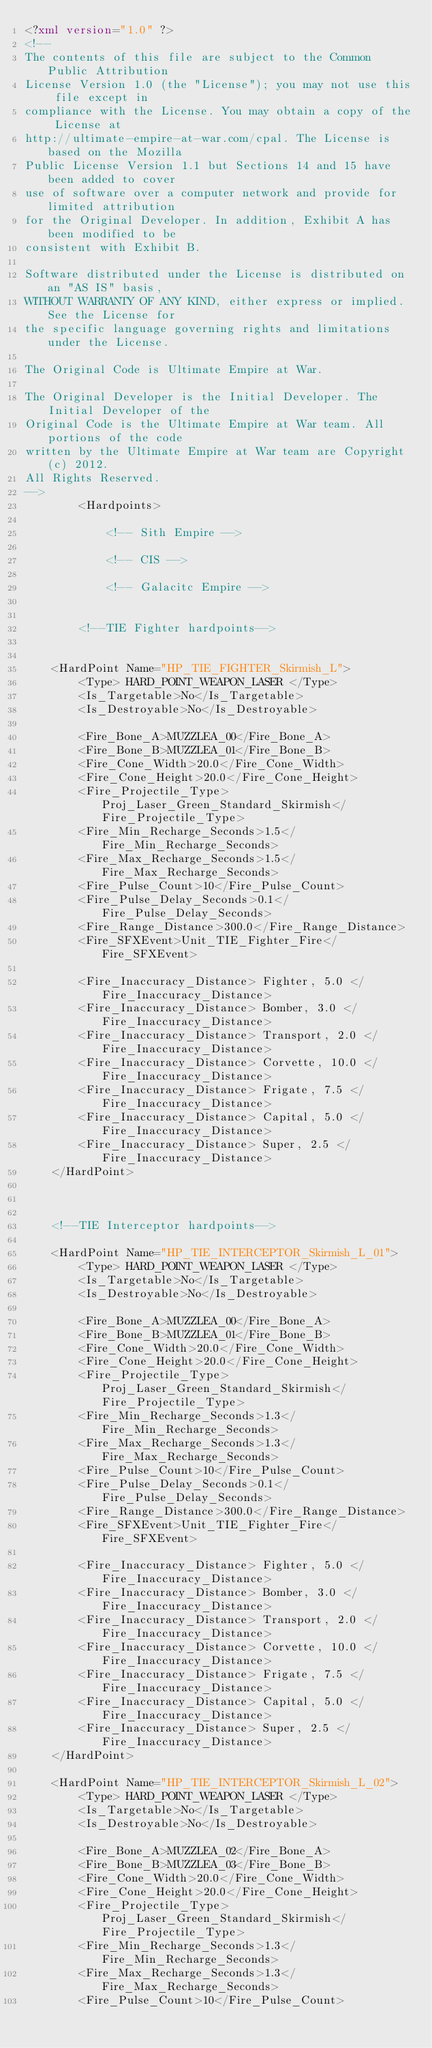Convert code to text. <code><loc_0><loc_0><loc_500><loc_500><_XML_><?xml version="1.0" ?>
<!--
The contents of this file are subject to the Common Public Attribution
License Version 1.0 (the "License"); you may not use this file except in
compliance with the License. You may obtain a copy of the License at
http://ultimate-empire-at-war.com/cpal. The License is based on the Mozilla
Public License Version 1.1 but Sections 14 and 15 have been added to cover
use of software over a computer network and provide for limited attribution
for the Original Developer. In addition, Exhibit A has been modified to be
consistent with Exhibit B.
    
Software distributed under the License is distributed on an "AS IS" basis,
WITHOUT WARRANTY OF ANY KIND, either express or implied. See the License for
the specific language governing rights and limitations under the License.
    
The Original Code is Ultimate Empire at War.
    
The Original Developer is the Initial Developer. The Initial Developer of the
Original Code is the Ultimate Empire at War team. All portions of the code
written by the Ultimate Empire at War team are Copyright (c) 2012.
All Rights Reserved.
-->
        <Hardpoints>

            <!-- Sith Empire -->

            <!-- CIS -->

            <!-- Galacitc Empire -->
			
				
		<!--TIE Fighter hardpoints-->
				
				
	<HardPoint Name="HP_TIE_FIGHTER_Skirmish_L">
		<Type> HARD_POINT_WEAPON_LASER </Type>
		<Is_Targetable>No</Is_Targetable>
		<Is_Destroyable>No</Is_Destroyable>

		<Fire_Bone_A>MUZZLEA_00</Fire_Bone_A>
		<Fire_Bone_B>MUZZLEA_01</Fire_Bone_B>
		<Fire_Cone_Width>20.0</Fire_Cone_Width>
		<Fire_Cone_Height>20.0</Fire_Cone_Height>
		<Fire_Projectile_Type>Proj_Laser_Green_Standard_Skirmish</Fire_Projectile_Type>
		<Fire_Min_Recharge_Seconds>1.5</Fire_Min_Recharge_Seconds>
		<Fire_Max_Recharge_Seconds>1.5</Fire_Max_Recharge_Seconds>
		<Fire_Pulse_Count>10</Fire_Pulse_Count>
		<Fire_Pulse_Delay_Seconds>0.1</Fire_Pulse_Delay_Seconds>
		<Fire_Range_Distance>300.0</Fire_Range_Distance>
		<Fire_SFXEvent>Unit_TIE_Fighter_Fire</Fire_SFXEvent>

		<Fire_Inaccuracy_Distance> Fighter, 5.0 </Fire_Inaccuracy_Distance>
		<Fire_Inaccuracy_Distance> Bomber, 3.0 </Fire_Inaccuracy_Distance>
		<Fire_Inaccuracy_Distance> Transport, 2.0 </Fire_Inaccuracy_Distance>
		<Fire_Inaccuracy_Distance> Corvette, 10.0 </Fire_Inaccuracy_Distance>
		<Fire_Inaccuracy_Distance> Frigate, 7.5 </Fire_Inaccuracy_Distance>
		<Fire_Inaccuracy_Distance> Capital, 5.0 </Fire_Inaccuracy_Distance>
		<Fire_Inaccuracy_Distance> Super, 2.5 </Fire_Inaccuracy_Distance>
	</HardPoint>



	<!--TIE Interceptor hardpoints-->

	<HardPoint Name="HP_TIE_INTERCEPTOR_Skirmish_L_01">
		<Type> HARD_POINT_WEAPON_LASER </Type>
		<Is_Targetable>No</Is_Targetable>
		<Is_Destroyable>No</Is_Destroyable>

		<Fire_Bone_A>MUZZLEA_00</Fire_Bone_A>
		<Fire_Bone_B>MUZZLEA_01</Fire_Bone_B>
		<Fire_Cone_Width>20.0</Fire_Cone_Width>
		<Fire_Cone_Height>20.0</Fire_Cone_Height>
		<Fire_Projectile_Type>Proj_Laser_Green_Standard_Skirmish</Fire_Projectile_Type>
		<Fire_Min_Recharge_Seconds>1.3</Fire_Min_Recharge_Seconds>
		<Fire_Max_Recharge_Seconds>1.3</Fire_Max_Recharge_Seconds>
		<Fire_Pulse_Count>10</Fire_Pulse_Count>
		<Fire_Pulse_Delay_Seconds>0.1</Fire_Pulse_Delay_Seconds>
		<Fire_Range_Distance>300.0</Fire_Range_Distance>
		<Fire_SFXEvent>Unit_TIE_Fighter_Fire</Fire_SFXEvent>

		<Fire_Inaccuracy_Distance> Fighter, 5.0 </Fire_Inaccuracy_Distance>
		<Fire_Inaccuracy_Distance> Bomber, 3.0 </Fire_Inaccuracy_Distance>
		<Fire_Inaccuracy_Distance> Transport, 2.0 </Fire_Inaccuracy_Distance>
		<Fire_Inaccuracy_Distance> Corvette, 10.0 </Fire_Inaccuracy_Distance>
		<Fire_Inaccuracy_Distance> Frigate, 7.5 </Fire_Inaccuracy_Distance>
		<Fire_Inaccuracy_Distance> Capital, 5.0 </Fire_Inaccuracy_Distance>
		<Fire_Inaccuracy_Distance> Super, 2.5 </Fire_Inaccuracy_Distance>
	</HardPoint>

	<HardPoint Name="HP_TIE_INTERCEPTOR_Skirmish_L_02">
		<Type> HARD_POINT_WEAPON_LASER </Type>
		<Is_Targetable>No</Is_Targetable>
		<Is_Destroyable>No</Is_Destroyable>

		<Fire_Bone_A>MUZZLEA_02</Fire_Bone_A>
		<Fire_Bone_B>MUZZLEA_03</Fire_Bone_B>
		<Fire_Cone_Width>20.0</Fire_Cone_Width>
		<Fire_Cone_Height>20.0</Fire_Cone_Height>
		<Fire_Projectile_Type>Proj_Laser_Green_Standard_Skirmish</Fire_Projectile_Type>
		<Fire_Min_Recharge_Seconds>1.3</Fire_Min_Recharge_Seconds>
		<Fire_Max_Recharge_Seconds>1.3</Fire_Max_Recharge_Seconds>
		<Fire_Pulse_Count>10</Fire_Pulse_Count></code> 